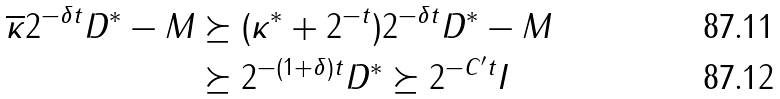<formula> <loc_0><loc_0><loc_500><loc_500>\overline { \kappa } 2 ^ { - \delta t } D ^ { \ast } - M & \succeq ( \kappa ^ { \ast } + 2 ^ { - t } ) 2 ^ { - \delta t } D ^ { \ast } - M \\ & \succeq 2 ^ { - ( 1 + \delta ) t } D ^ { \ast } \succeq 2 ^ { - C ^ { \prime } t } I</formula> 